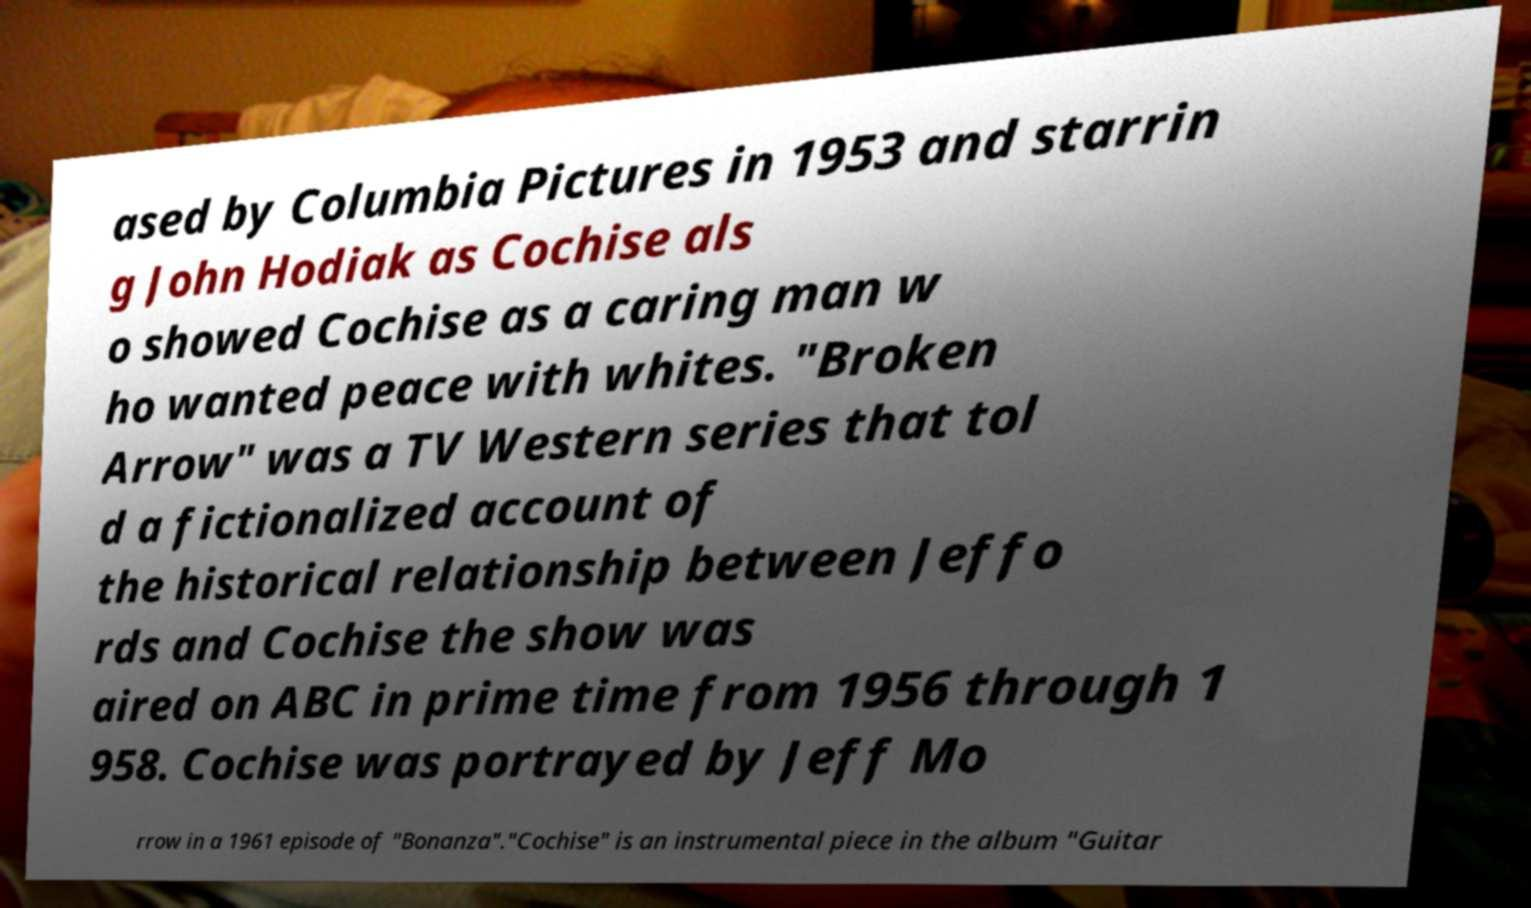Could you assist in decoding the text presented in this image and type it out clearly? ased by Columbia Pictures in 1953 and starrin g John Hodiak as Cochise als o showed Cochise as a caring man w ho wanted peace with whites. "Broken Arrow" was a TV Western series that tol d a fictionalized account of the historical relationship between Jeffo rds and Cochise the show was aired on ABC in prime time from 1956 through 1 958. Cochise was portrayed by Jeff Mo rrow in a 1961 episode of "Bonanza"."Cochise" is an instrumental piece in the album "Guitar 